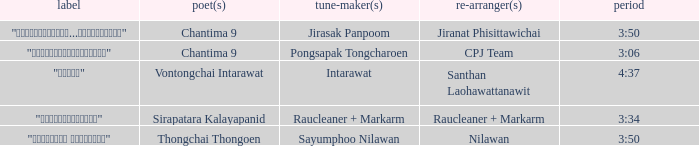Who was the arranger for the song that had a lyricist of Sirapatara Kalayapanid? Raucleaner + Markarm. 